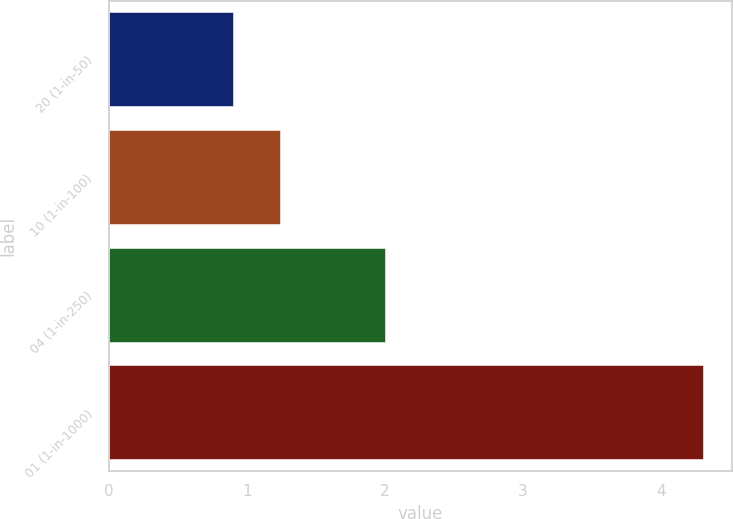<chart> <loc_0><loc_0><loc_500><loc_500><bar_chart><fcel>20 (1-in-50)<fcel>10 (1-in-100)<fcel>04 (1-in-250)<fcel>01 (1-in-1000)<nl><fcel>0.9<fcel>1.24<fcel>2<fcel>4.3<nl></chart> 